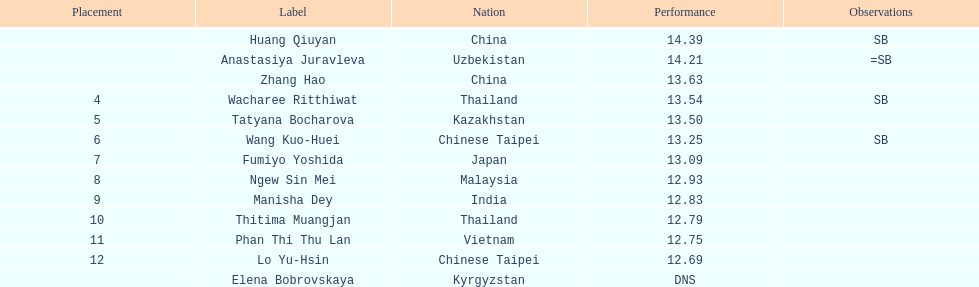How extensive was manisha dey's jump? 12.83. 